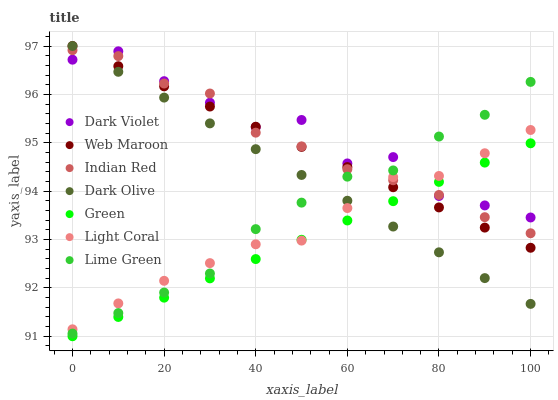Does Green have the minimum area under the curve?
Answer yes or no. Yes. Does Dark Violet have the maximum area under the curve?
Answer yes or no. Yes. Does Web Maroon have the minimum area under the curve?
Answer yes or no. No. Does Web Maroon have the maximum area under the curve?
Answer yes or no. No. Is Green the smoothest?
Answer yes or no. Yes. Is Dark Violet the roughest?
Answer yes or no. Yes. Is Web Maroon the smoothest?
Answer yes or no. No. Is Web Maroon the roughest?
Answer yes or no. No. Does Green have the lowest value?
Answer yes or no. Yes. Does Web Maroon have the lowest value?
Answer yes or no. No. Does Web Maroon have the highest value?
Answer yes or no. Yes. Does Dark Violet have the highest value?
Answer yes or no. No. Is Green less than Lime Green?
Answer yes or no. Yes. Is Lime Green greater than Green?
Answer yes or no. Yes. Does Dark Violet intersect Green?
Answer yes or no. Yes. Is Dark Violet less than Green?
Answer yes or no. No. Is Dark Violet greater than Green?
Answer yes or no. No. Does Green intersect Lime Green?
Answer yes or no. No. 